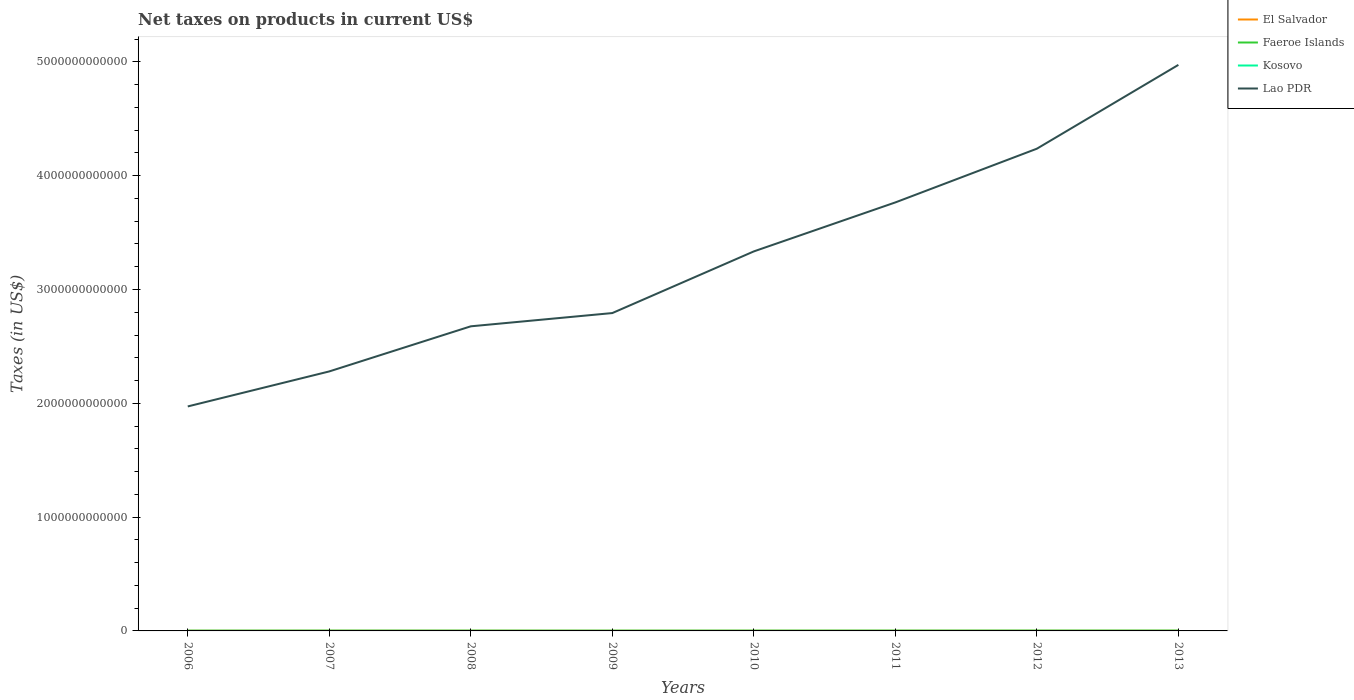How many different coloured lines are there?
Provide a short and direct response. 4. Across all years, what is the maximum net taxes on products in Lao PDR?
Keep it short and to the point. 1.97e+12. In which year was the net taxes on products in Lao PDR maximum?
Provide a succinct answer. 2006. What is the total net taxes on products in Lao PDR in the graph?
Your answer should be very brief. -5.42e+11. What is the difference between the highest and the second highest net taxes on products in Faeroe Islands?
Keep it short and to the point. 2.97e+08. Is the net taxes on products in El Salvador strictly greater than the net taxes on products in Kosovo over the years?
Your response must be concise. No. What is the difference between two consecutive major ticks on the Y-axis?
Your answer should be compact. 1.00e+12. Does the graph contain grids?
Your answer should be very brief. No. Where does the legend appear in the graph?
Provide a short and direct response. Top right. How are the legend labels stacked?
Your response must be concise. Vertical. What is the title of the graph?
Provide a short and direct response. Net taxes on products in current US$. Does "Belize" appear as one of the legend labels in the graph?
Ensure brevity in your answer.  No. What is the label or title of the Y-axis?
Your response must be concise. Taxes (in US$). What is the Taxes (in US$) of El Salvador in 2006?
Your response must be concise. 1.50e+09. What is the Taxes (in US$) in Faeroe Islands in 2006?
Provide a short and direct response. 1.68e+09. What is the Taxes (in US$) of Kosovo in 2006?
Ensure brevity in your answer.  5.34e+08. What is the Taxes (in US$) in Lao PDR in 2006?
Ensure brevity in your answer.  1.97e+12. What is the Taxes (in US$) in El Salvador in 2007?
Keep it short and to the point. 1.69e+09. What is the Taxes (in US$) in Faeroe Islands in 2007?
Your response must be concise. 1.88e+09. What is the Taxes (in US$) in Kosovo in 2007?
Your answer should be compact. 5.87e+08. What is the Taxes (in US$) in Lao PDR in 2007?
Provide a short and direct response. 2.28e+12. What is the Taxes (in US$) of El Salvador in 2008?
Keep it short and to the point. 1.77e+09. What is the Taxes (in US$) in Faeroe Islands in 2008?
Give a very brief answer. 1.78e+09. What is the Taxes (in US$) in Kosovo in 2008?
Your answer should be very brief. 5.91e+08. What is the Taxes (in US$) of Lao PDR in 2008?
Your answer should be compact. 2.68e+12. What is the Taxes (in US$) of El Salvador in 2009?
Keep it short and to the point. 1.52e+09. What is the Taxes (in US$) of Faeroe Islands in 2009?
Provide a succinct answer. 1.58e+09. What is the Taxes (in US$) in Kosovo in 2009?
Give a very brief answer. 6.11e+08. What is the Taxes (in US$) of Lao PDR in 2009?
Keep it short and to the point. 2.79e+12. What is the Taxes (in US$) of El Salvador in 2010?
Your answer should be compact. 1.69e+09. What is the Taxes (in US$) in Faeroe Islands in 2010?
Your answer should be compact. 1.67e+09. What is the Taxes (in US$) in Kosovo in 2010?
Your response must be concise. 7.15e+08. What is the Taxes (in US$) of Lao PDR in 2010?
Make the answer very short. 3.33e+12. What is the Taxes (in US$) of El Salvador in 2011?
Ensure brevity in your answer.  1.95e+09. What is the Taxes (in US$) in Faeroe Islands in 2011?
Your answer should be very brief. 1.65e+09. What is the Taxes (in US$) in Kosovo in 2011?
Make the answer very short. 8.70e+08. What is the Taxes (in US$) in Lao PDR in 2011?
Offer a very short reply. 3.76e+12. What is the Taxes (in US$) in El Salvador in 2012?
Offer a very short reply. 2.03e+09. What is the Taxes (in US$) in Faeroe Islands in 2012?
Provide a short and direct response. 1.71e+09. What is the Taxes (in US$) in Kosovo in 2012?
Your response must be concise. 8.92e+08. What is the Taxes (in US$) of Lao PDR in 2012?
Provide a short and direct response. 4.24e+12. What is the Taxes (in US$) in El Salvador in 2013?
Offer a terse response. 2.10e+09. What is the Taxes (in US$) in Faeroe Islands in 2013?
Provide a short and direct response. 1.69e+09. What is the Taxes (in US$) of Kosovo in 2013?
Offer a terse response. 8.91e+08. What is the Taxes (in US$) of Lao PDR in 2013?
Your answer should be very brief. 4.97e+12. Across all years, what is the maximum Taxes (in US$) of El Salvador?
Make the answer very short. 2.10e+09. Across all years, what is the maximum Taxes (in US$) in Faeroe Islands?
Give a very brief answer. 1.88e+09. Across all years, what is the maximum Taxes (in US$) of Kosovo?
Make the answer very short. 8.92e+08. Across all years, what is the maximum Taxes (in US$) in Lao PDR?
Provide a short and direct response. 4.97e+12. Across all years, what is the minimum Taxes (in US$) of El Salvador?
Give a very brief answer. 1.50e+09. Across all years, what is the minimum Taxes (in US$) of Faeroe Islands?
Offer a very short reply. 1.58e+09. Across all years, what is the minimum Taxes (in US$) of Kosovo?
Offer a very short reply. 5.34e+08. Across all years, what is the minimum Taxes (in US$) of Lao PDR?
Provide a succinct answer. 1.97e+12. What is the total Taxes (in US$) of El Salvador in the graph?
Keep it short and to the point. 1.42e+1. What is the total Taxes (in US$) in Faeroe Islands in the graph?
Your answer should be very brief. 1.36e+1. What is the total Taxes (in US$) in Kosovo in the graph?
Offer a terse response. 5.69e+09. What is the total Taxes (in US$) of Lao PDR in the graph?
Provide a succinct answer. 2.60e+13. What is the difference between the Taxes (in US$) in El Salvador in 2006 and that in 2007?
Offer a very short reply. -1.87e+08. What is the difference between the Taxes (in US$) in Faeroe Islands in 2006 and that in 2007?
Keep it short and to the point. -1.99e+08. What is the difference between the Taxes (in US$) of Kosovo in 2006 and that in 2007?
Your answer should be compact. -5.33e+07. What is the difference between the Taxes (in US$) of Lao PDR in 2006 and that in 2007?
Your response must be concise. -3.08e+11. What is the difference between the Taxes (in US$) in El Salvador in 2006 and that in 2008?
Your response must be concise. -2.76e+08. What is the difference between the Taxes (in US$) of Faeroe Islands in 2006 and that in 2008?
Your answer should be very brief. -1.00e+08. What is the difference between the Taxes (in US$) of Kosovo in 2006 and that in 2008?
Your answer should be compact. -5.71e+07. What is the difference between the Taxes (in US$) in Lao PDR in 2006 and that in 2008?
Make the answer very short. -7.04e+11. What is the difference between the Taxes (in US$) of El Salvador in 2006 and that in 2009?
Your answer should be compact. -2.01e+07. What is the difference between the Taxes (in US$) in Faeroe Islands in 2006 and that in 2009?
Offer a very short reply. 9.80e+07. What is the difference between the Taxes (in US$) of Kosovo in 2006 and that in 2009?
Offer a terse response. -7.67e+07. What is the difference between the Taxes (in US$) of Lao PDR in 2006 and that in 2009?
Your response must be concise. -8.20e+11. What is the difference between the Taxes (in US$) of El Salvador in 2006 and that in 2010?
Offer a very short reply. -1.89e+08. What is the difference between the Taxes (in US$) in Faeroe Islands in 2006 and that in 2010?
Make the answer very short. 1.70e+07. What is the difference between the Taxes (in US$) of Kosovo in 2006 and that in 2010?
Make the answer very short. -1.81e+08. What is the difference between the Taxes (in US$) of Lao PDR in 2006 and that in 2010?
Offer a very short reply. -1.36e+12. What is the difference between the Taxes (in US$) of El Salvador in 2006 and that in 2011?
Your answer should be compact. -4.52e+08. What is the difference between the Taxes (in US$) of Faeroe Islands in 2006 and that in 2011?
Make the answer very short. 3.50e+07. What is the difference between the Taxes (in US$) in Kosovo in 2006 and that in 2011?
Make the answer very short. -3.36e+08. What is the difference between the Taxes (in US$) in Lao PDR in 2006 and that in 2011?
Make the answer very short. -1.79e+12. What is the difference between the Taxes (in US$) in El Salvador in 2006 and that in 2012?
Give a very brief answer. -5.32e+08. What is the difference between the Taxes (in US$) of Faeroe Islands in 2006 and that in 2012?
Your answer should be very brief. -2.30e+07. What is the difference between the Taxes (in US$) of Kosovo in 2006 and that in 2012?
Offer a terse response. -3.58e+08. What is the difference between the Taxes (in US$) in Lao PDR in 2006 and that in 2012?
Offer a very short reply. -2.26e+12. What is the difference between the Taxes (in US$) in El Salvador in 2006 and that in 2013?
Your answer should be compact. -5.97e+08. What is the difference between the Taxes (in US$) of Faeroe Islands in 2006 and that in 2013?
Keep it short and to the point. -1.00e+07. What is the difference between the Taxes (in US$) in Kosovo in 2006 and that in 2013?
Provide a succinct answer. -3.57e+08. What is the difference between the Taxes (in US$) of Lao PDR in 2006 and that in 2013?
Offer a terse response. -3.00e+12. What is the difference between the Taxes (in US$) in El Salvador in 2007 and that in 2008?
Keep it short and to the point. -8.86e+07. What is the difference between the Taxes (in US$) in Faeroe Islands in 2007 and that in 2008?
Provide a succinct answer. 9.90e+07. What is the difference between the Taxes (in US$) of Kosovo in 2007 and that in 2008?
Your answer should be very brief. -3.80e+06. What is the difference between the Taxes (in US$) in Lao PDR in 2007 and that in 2008?
Your answer should be compact. -3.96e+11. What is the difference between the Taxes (in US$) in El Salvador in 2007 and that in 2009?
Your answer should be very brief. 1.67e+08. What is the difference between the Taxes (in US$) in Faeroe Islands in 2007 and that in 2009?
Your answer should be compact. 2.97e+08. What is the difference between the Taxes (in US$) of Kosovo in 2007 and that in 2009?
Ensure brevity in your answer.  -2.34e+07. What is the difference between the Taxes (in US$) of Lao PDR in 2007 and that in 2009?
Your answer should be compact. -5.13e+11. What is the difference between the Taxes (in US$) in El Salvador in 2007 and that in 2010?
Give a very brief answer. -1.50e+06. What is the difference between the Taxes (in US$) of Faeroe Islands in 2007 and that in 2010?
Make the answer very short. 2.16e+08. What is the difference between the Taxes (in US$) in Kosovo in 2007 and that in 2010?
Your response must be concise. -1.28e+08. What is the difference between the Taxes (in US$) of Lao PDR in 2007 and that in 2010?
Give a very brief answer. -1.05e+12. What is the difference between the Taxes (in US$) of El Salvador in 2007 and that in 2011?
Your answer should be compact. -2.65e+08. What is the difference between the Taxes (in US$) of Faeroe Islands in 2007 and that in 2011?
Your answer should be very brief. 2.34e+08. What is the difference between the Taxes (in US$) of Kosovo in 2007 and that in 2011?
Provide a short and direct response. -2.82e+08. What is the difference between the Taxes (in US$) in Lao PDR in 2007 and that in 2011?
Provide a succinct answer. -1.48e+12. What is the difference between the Taxes (in US$) in El Salvador in 2007 and that in 2012?
Provide a succinct answer. -3.45e+08. What is the difference between the Taxes (in US$) in Faeroe Islands in 2007 and that in 2012?
Offer a very short reply. 1.76e+08. What is the difference between the Taxes (in US$) in Kosovo in 2007 and that in 2012?
Give a very brief answer. -3.04e+08. What is the difference between the Taxes (in US$) in Lao PDR in 2007 and that in 2012?
Provide a succinct answer. -1.96e+12. What is the difference between the Taxes (in US$) of El Salvador in 2007 and that in 2013?
Provide a succinct answer. -4.10e+08. What is the difference between the Taxes (in US$) in Faeroe Islands in 2007 and that in 2013?
Keep it short and to the point. 1.89e+08. What is the difference between the Taxes (in US$) in Kosovo in 2007 and that in 2013?
Give a very brief answer. -3.04e+08. What is the difference between the Taxes (in US$) in Lao PDR in 2007 and that in 2013?
Ensure brevity in your answer.  -2.69e+12. What is the difference between the Taxes (in US$) of El Salvador in 2008 and that in 2009?
Give a very brief answer. 2.56e+08. What is the difference between the Taxes (in US$) in Faeroe Islands in 2008 and that in 2009?
Provide a short and direct response. 1.98e+08. What is the difference between the Taxes (in US$) of Kosovo in 2008 and that in 2009?
Offer a very short reply. -1.96e+07. What is the difference between the Taxes (in US$) of Lao PDR in 2008 and that in 2009?
Your answer should be compact. -1.16e+11. What is the difference between the Taxes (in US$) in El Salvador in 2008 and that in 2010?
Keep it short and to the point. 8.71e+07. What is the difference between the Taxes (in US$) in Faeroe Islands in 2008 and that in 2010?
Provide a short and direct response. 1.17e+08. What is the difference between the Taxes (in US$) of Kosovo in 2008 and that in 2010?
Provide a short and direct response. -1.24e+08. What is the difference between the Taxes (in US$) in Lao PDR in 2008 and that in 2010?
Keep it short and to the point. -6.58e+11. What is the difference between the Taxes (in US$) in El Salvador in 2008 and that in 2011?
Keep it short and to the point. -1.76e+08. What is the difference between the Taxes (in US$) of Faeroe Islands in 2008 and that in 2011?
Provide a succinct answer. 1.35e+08. What is the difference between the Taxes (in US$) of Kosovo in 2008 and that in 2011?
Offer a very short reply. -2.79e+08. What is the difference between the Taxes (in US$) of Lao PDR in 2008 and that in 2011?
Offer a very short reply. -1.09e+12. What is the difference between the Taxes (in US$) of El Salvador in 2008 and that in 2012?
Ensure brevity in your answer.  -2.56e+08. What is the difference between the Taxes (in US$) of Faeroe Islands in 2008 and that in 2012?
Your answer should be compact. 7.70e+07. What is the difference between the Taxes (in US$) in Kosovo in 2008 and that in 2012?
Your answer should be compact. -3.01e+08. What is the difference between the Taxes (in US$) in Lao PDR in 2008 and that in 2012?
Your answer should be compact. -1.56e+12. What is the difference between the Taxes (in US$) in El Salvador in 2008 and that in 2013?
Give a very brief answer. -3.22e+08. What is the difference between the Taxes (in US$) in Faeroe Islands in 2008 and that in 2013?
Your response must be concise. 9.00e+07. What is the difference between the Taxes (in US$) in Kosovo in 2008 and that in 2013?
Provide a succinct answer. -3.00e+08. What is the difference between the Taxes (in US$) of Lao PDR in 2008 and that in 2013?
Your answer should be compact. -2.30e+12. What is the difference between the Taxes (in US$) in El Salvador in 2009 and that in 2010?
Your answer should be very brief. -1.68e+08. What is the difference between the Taxes (in US$) of Faeroe Islands in 2009 and that in 2010?
Offer a terse response. -8.10e+07. What is the difference between the Taxes (in US$) in Kosovo in 2009 and that in 2010?
Give a very brief answer. -1.04e+08. What is the difference between the Taxes (in US$) in Lao PDR in 2009 and that in 2010?
Provide a succinct answer. -5.42e+11. What is the difference between the Taxes (in US$) in El Salvador in 2009 and that in 2011?
Offer a terse response. -4.32e+08. What is the difference between the Taxes (in US$) of Faeroe Islands in 2009 and that in 2011?
Keep it short and to the point. -6.30e+07. What is the difference between the Taxes (in US$) in Kosovo in 2009 and that in 2011?
Make the answer very short. -2.59e+08. What is the difference between the Taxes (in US$) in Lao PDR in 2009 and that in 2011?
Your answer should be very brief. -9.72e+11. What is the difference between the Taxes (in US$) in El Salvador in 2009 and that in 2012?
Your answer should be very brief. -5.12e+08. What is the difference between the Taxes (in US$) in Faeroe Islands in 2009 and that in 2012?
Your answer should be compact. -1.21e+08. What is the difference between the Taxes (in US$) of Kosovo in 2009 and that in 2012?
Provide a succinct answer. -2.81e+08. What is the difference between the Taxes (in US$) of Lao PDR in 2009 and that in 2012?
Your answer should be compact. -1.44e+12. What is the difference between the Taxes (in US$) of El Salvador in 2009 and that in 2013?
Provide a short and direct response. -5.77e+08. What is the difference between the Taxes (in US$) of Faeroe Islands in 2009 and that in 2013?
Keep it short and to the point. -1.08e+08. What is the difference between the Taxes (in US$) in Kosovo in 2009 and that in 2013?
Offer a terse response. -2.80e+08. What is the difference between the Taxes (in US$) of Lao PDR in 2009 and that in 2013?
Offer a terse response. -2.18e+12. What is the difference between the Taxes (in US$) in El Salvador in 2010 and that in 2011?
Give a very brief answer. -2.64e+08. What is the difference between the Taxes (in US$) of Faeroe Islands in 2010 and that in 2011?
Your answer should be compact. 1.80e+07. What is the difference between the Taxes (in US$) of Kosovo in 2010 and that in 2011?
Ensure brevity in your answer.  -1.55e+08. What is the difference between the Taxes (in US$) of Lao PDR in 2010 and that in 2011?
Your answer should be compact. -4.30e+11. What is the difference between the Taxes (in US$) in El Salvador in 2010 and that in 2012?
Give a very brief answer. -3.44e+08. What is the difference between the Taxes (in US$) of Faeroe Islands in 2010 and that in 2012?
Your answer should be compact. -4.00e+07. What is the difference between the Taxes (in US$) of Kosovo in 2010 and that in 2012?
Your answer should be compact. -1.77e+08. What is the difference between the Taxes (in US$) of Lao PDR in 2010 and that in 2012?
Offer a very short reply. -9.02e+11. What is the difference between the Taxes (in US$) of El Salvador in 2010 and that in 2013?
Make the answer very short. -4.09e+08. What is the difference between the Taxes (in US$) in Faeroe Islands in 2010 and that in 2013?
Your response must be concise. -2.70e+07. What is the difference between the Taxes (in US$) in Kosovo in 2010 and that in 2013?
Make the answer very short. -1.76e+08. What is the difference between the Taxes (in US$) in Lao PDR in 2010 and that in 2013?
Provide a short and direct response. -1.64e+12. What is the difference between the Taxes (in US$) of El Salvador in 2011 and that in 2012?
Ensure brevity in your answer.  -8.00e+07. What is the difference between the Taxes (in US$) of Faeroe Islands in 2011 and that in 2012?
Your response must be concise. -5.80e+07. What is the difference between the Taxes (in US$) in Kosovo in 2011 and that in 2012?
Offer a very short reply. -2.21e+07. What is the difference between the Taxes (in US$) of Lao PDR in 2011 and that in 2012?
Give a very brief answer. -4.72e+11. What is the difference between the Taxes (in US$) in El Salvador in 2011 and that in 2013?
Provide a succinct answer. -1.45e+08. What is the difference between the Taxes (in US$) of Faeroe Islands in 2011 and that in 2013?
Your answer should be compact. -4.50e+07. What is the difference between the Taxes (in US$) in Kosovo in 2011 and that in 2013?
Your response must be concise. -2.14e+07. What is the difference between the Taxes (in US$) of Lao PDR in 2011 and that in 2013?
Your response must be concise. -1.21e+12. What is the difference between the Taxes (in US$) in El Salvador in 2012 and that in 2013?
Make the answer very short. -6.53e+07. What is the difference between the Taxes (in US$) of Faeroe Islands in 2012 and that in 2013?
Ensure brevity in your answer.  1.30e+07. What is the difference between the Taxes (in US$) of Lao PDR in 2012 and that in 2013?
Give a very brief answer. -7.37e+11. What is the difference between the Taxes (in US$) of El Salvador in 2006 and the Taxes (in US$) of Faeroe Islands in 2007?
Keep it short and to the point. -3.83e+08. What is the difference between the Taxes (in US$) in El Salvador in 2006 and the Taxes (in US$) in Kosovo in 2007?
Give a very brief answer. 9.11e+08. What is the difference between the Taxes (in US$) in El Salvador in 2006 and the Taxes (in US$) in Lao PDR in 2007?
Give a very brief answer. -2.28e+12. What is the difference between the Taxes (in US$) of Faeroe Islands in 2006 and the Taxes (in US$) of Kosovo in 2007?
Offer a very short reply. 1.10e+09. What is the difference between the Taxes (in US$) in Faeroe Islands in 2006 and the Taxes (in US$) in Lao PDR in 2007?
Your response must be concise. -2.28e+12. What is the difference between the Taxes (in US$) in Kosovo in 2006 and the Taxes (in US$) in Lao PDR in 2007?
Provide a short and direct response. -2.28e+12. What is the difference between the Taxes (in US$) of El Salvador in 2006 and the Taxes (in US$) of Faeroe Islands in 2008?
Your response must be concise. -2.84e+08. What is the difference between the Taxes (in US$) in El Salvador in 2006 and the Taxes (in US$) in Kosovo in 2008?
Give a very brief answer. 9.08e+08. What is the difference between the Taxes (in US$) of El Salvador in 2006 and the Taxes (in US$) of Lao PDR in 2008?
Offer a terse response. -2.67e+12. What is the difference between the Taxes (in US$) in Faeroe Islands in 2006 and the Taxes (in US$) in Kosovo in 2008?
Offer a terse response. 1.09e+09. What is the difference between the Taxes (in US$) in Faeroe Islands in 2006 and the Taxes (in US$) in Lao PDR in 2008?
Keep it short and to the point. -2.67e+12. What is the difference between the Taxes (in US$) in Kosovo in 2006 and the Taxes (in US$) in Lao PDR in 2008?
Make the answer very short. -2.68e+12. What is the difference between the Taxes (in US$) of El Salvador in 2006 and the Taxes (in US$) of Faeroe Islands in 2009?
Keep it short and to the point. -8.64e+07. What is the difference between the Taxes (in US$) in El Salvador in 2006 and the Taxes (in US$) in Kosovo in 2009?
Your response must be concise. 8.88e+08. What is the difference between the Taxes (in US$) in El Salvador in 2006 and the Taxes (in US$) in Lao PDR in 2009?
Your answer should be compact. -2.79e+12. What is the difference between the Taxes (in US$) in Faeroe Islands in 2006 and the Taxes (in US$) in Kosovo in 2009?
Ensure brevity in your answer.  1.07e+09. What is the difference between the Taxes (in US$) of Faeroe Islands in 2006 and the Taxes (in US$) of Lao PDR in 2009?
Offer a terse response. -2.79e+12. What is the difference between the Taxes (in US$) in Kosovo in 2006 and the Taxes (in US$) in Lao PDR in 2009?
Provide a short and direct response. -2.79e+12. What is the difference between the Taxes (in US$) of El Salvador in 2006 and the Taxes (in US$) of Faeroe Islands in 2010?
Give a very brief answer. -1.67e+08. What is the difference between the Taxes (in US$) of El Salvador in 2006 and the Taxes (in US$) of Kosovo in 2010?
Ensure brevity in your answer.  7.84e+08. What is the difference between the Taxes (in US$) in El Salvador in 2006 and the Taxes (in US$) in Lao PDR in 2010?
Your answer should be very brief. -3.33e+12. What is the difference between the Taxes (in US$) in Faeroe Islands in 2006 and the Taxes (in US$) in Kosovo in 2010?
Provide a succinct answer. 9.68e+08. What is the difference between the Taxes (in US$) of Faeroe Islands in 2006 and the Taxes (in US$) of Lao PDR in 2010?
Offer a very short reply. -3.33e+12. What is the difference between the Taxes (in US$) in Kosovo in 2006 and the Taxes (in US$) in Lao PDR in 2010?
Offer a terse response. -3.33e+12. What is the difference between the Taxes (in US$) of El Salvador in 2006 and the Taxes (in US$) of Faeroe Islands in 2011?
Keep it short and to the point. -1.49e+08. What is the difference between the Taxes (in US$) of El Salvador in 2006 and the Taxes (in US$) of Kosovo in 2011?
Your answer should be very brief. 6.29e+08. What is the difference between the Taxes (in US$) of El Salvador in 2006 and the Taxes (in US$) of Lao PDR in 2011?
Offer a very short reply. -3.76e+12. What is the difference between the Taxes (in US$) in Faeroe Islands in 2006 and the Taxes (in US$) in Kosovo in 2011?
Make the answer very short. 8.13e+08. What is the difference between the Taxes (in US$) in Faeroe Islands in 2006 and the Taxes (in US$) in Lao PDR in 2011?
Make the answer very short. -3.76e+12. What is the difference between the Taxes (in US$) in Kosovo in 2006 and the Taxes (in US$) in Lao PDR in 2011?
Your response must be concise. -3.76e+12. What is the difference between the Taxes (in US$) in El Salvador in 2006 and the Taxes (in US$) in Faeroe Islands in 2012?
Ensure brevity in your answer.  -2.07e+08. What is the difference between the Taxes (in US$) in El Salvador in 2006 and the Taxes (in US$) in Kosovo in 2012?
Provide a short and direct response. 6.07e+08. What is the difference between the Taxes (in US$) of El Salvador in 2006 and the Taxes (in US$) of Lao PDR in 2012?
Your answer should be compact. -4.24e+12. What is the difference between the Taxes (in US$) in Faeroe Islands in 2006 and the Taxes (in US$) in Kosovo in 2012?
Keep it short and to the point. 7.91e+08. What is the difference between the Taxes (in US$) of Faeroe Islands in 2006 and the Taxes (in US$) of Lao PDR in 2012?
Make the answer very short. -4.24e+12. What is the difference between the Taxes (in US$) of Kosovo in 2006 and the Taxes (in US$) of Lao PDR in 2012?
Keep it short and to the point. -4.24e+12. What is the difference between the Taxes (in US$) in El Salvador in 2006 and the Taxes (in US$) in Faeroe Islands in 2013?
Keep it short and to the point. -1.94e+08. What is the difference between the Taxes (in US$) in El Salvador in 2006 and the Taxes (in US$) in Kosovo in 2013?
Offer a terse response. 6.08e+08. What is the difference between the Taxes (in US$) in El Salvador in 2006 and the Taxes (in US$) in Lao PDR in 2013?
Your answer should be very brief. -4.97e+12. What is the difference between the Taxes (in US$) in Faeroe Islands in 2006 and the Taxes (in US$) in Kosovo in 2013?
Make the answer very short. 7.92e+08. What is the difference between the Taxes (in US$) of Faeroe Islands in 2006 and the Taxes (in US$) of Lao PDR in 2013?
Provide a succinct answer. -4.97e+12. What is the difference between the Taxes (in US$) in Kosovo in 2006 and the Taxes (in US$) in Lao PDR in 2013?
Provide a short and direct response. -4.97e+12. What is the difference between the Taxes (in US$) of El Salvador in 2007 and the Taxes (in US$) of Faeroe Islands in 2008?
Give a very brief answer. -9.73e+07. What is the difference between the Taxes (in US$) in El Salvador in 2007 and the Taxes (in US$) in Kosovo in 2008?
Your answer should be very brief. 1.09e+09. What is the difference between the Taxes (in US$) of El Salvador in 2007 and the Taxes (in US$) of Lao PDR in 2008?
Your response must be concise. -2.67e+12. What is the difference between the Taxes (in US$) of Faeroe Islands in 2007 and the Taxes (in US$) of Kosovo in 2008?
Provide a short and direct response. 1.29e+09. What is the difference between the Taxes (in US$) in Faeroe Islands in 2007 and the Taxes (in US$) in Lao PDR in 2008?
Give a very brief answer. -2.67e+12. What is the difference between the Taxes (in US$) in Kosovo in 2007 and the Taxes (in US$) in Lao PDR in 2008?
Your response must be concise. -2.68e+12. What is the difference between the Taxes (in US$) of El Salvador in 2007 and the Taxes (in US$) of Faeroe Islands in 2009?
Your answer should be compact. 1.01e+08. What is the difference between the Taxes (in US$) of El Salvador in 2007 and the Taxes (in US$) of Kosovo in 2009?
Ensure brevity in your answer.  1.08e+09. What is the difference between the Taxes (in US$) in El Salvador in 2007 and the Taxes (in US$) in Lao PDR in 2009?
Give a very brief answer. -2.79e+12. What is the difference between the Taxes (in US$) in Faeroe Islands in 2007 and the Taxes (in US$) in Kosovo in 2009?
Keep it short and to the point. 1.27e+09. What is the difference between the Taxes (in US$) of Faeroe Islands in 2007 and the Taxes (in US$) of Lao PDR in 2009?
Provide a short and direct response. -2.79e+12. What is the difference between the Taxes (in US$) of Kosovo in 2007 and the Taxes (in US$) of Lao PDR in 2009?
Provide a short and direct response. -2.79e+12. What is the difference between the Taxes (in US$) of El Salvador in 2007 and the Taxes (in US$) of Faeroe Islands in 2010?
Your answer should be compact. 1.97e+07. What is the difference between the Taxes (in US$) in El Salvador in 2007 and the Taxes (in US$) in Kosovo in 2010?
Provide a short and direct response. 9.71e+08. What is the difference between the Taxes (in US$) of El Salvador in 2007 and the Taxes (in US$) of Lao PDR in 2010?
Your response must be concise. -3.33e+12. What is the difference between the Taxes (in US$) in Faeroe Islands in 2007 and the Taxes (in US$) in Kosovo in 2010?
Make the answer very short. 1.17e+09. What is the difference between the Taxes (in US$) in Faeroe Islands in 2007 and the Taxes (in US$) in Lao PDR in 2010?
Give a very brief answer. -3.33e+12. What is the difference between the Taxes (in US$) of Kosovo in 2007 and the Taxes (in US$) of Lao PDR in 2010?
Make the answer very short. -3.33e+12. What is the difference between the Taxes (in US$) of El Salvador in 2007 and the Taxes (in US$) of Faeroe Islands in 2011?
Your response must be concise. 3.77e+07. What is the difference between the Taxes (in US$) in El Salvador in 2007 and the Taxes (in US$) in Kosovo in 2011?
Offer a very short reply. 8.16e+08. What is the difference between the Taxes (in US$) in El Salvador in 2007 and the Taxes (in US$) in Lao PDR in 2011?
Make the answer very short. -3.76e+12. What is the difference between the Taxes (in US$) of Faeroe Islands in 2007 and the Taxes (in US$) of Kosovo in 2011?
Provide a succinct answer. 1.01e+09. What is the difference between the Taxes (in US$) in Faeroe Islands in 2007 and the Taxes (in US$) in Lao PDR in 2011?
Your answer should be compact. -3.76e+12. What is the difference between the Taxes (in US$) in Kosovo in 2007 and the Taxes (in US$) in Lao PDR in 2011?
Your answer should be compact. -3.76e+12. What is the difference between the Taxes (in US$) in El Salvador in 2007 and the Taxes (in US$) in Faeroe Islands in 2012?
Provide a short and direct response. -2.03e+07. What is the difference between the Taxes (in US$) in El Salvador in 2007 and the Taxes (in US$) in Kosovo in 2012?
Your answer should be compact. 7.94e+08. What is the difference between the Taxes (in US$) of El Salvador in 2007 and the Taxes (in US$) of Lao PDR in 2012?
Keep it short and to the point. -4.24e+12. What is the difference between the Taxes (in US$) of Faeroe Islands in 2007 and the Taxes (in US$) of Kosovo in 2012?
Provide a short and direct response. 9.90e+08. What is the difference between the Taxes (in US$) in Faeroe Islands in 2007 and the Taxes (in US$) in Lao PDR in 2012?
Make the answer very short. -4.24e+12. What is the difference between the Taxes (in US$) of Kosovo in 2007 and the Taxes (in US$) of Lao PDR in 2012?
Ensure brevity in your answer.  -4.24e+12. What is the difference between the Taxes (in US$) of El Salvador in 2007 and the Taxes (in US$) of Faeroe Islands in 2013?
Provide a succinct answer. -7.30e+06. What is the difference between the Taxes (in US$) in El Salvador in 2007 and the Taxes (in US$) in Kosovo in 2013?
Offer a terse response. 7.95e+08. What is the difference between the Taxes (in US$) in El Salvador in 2007 and the Taxes (in US$) in Lao PDR in 2013?
Provide a succinct answer. -4.97e+12. What is the difference between the Taxes (in US$) in Faeroe Islands in 2007 and the Taxes (in US$) in Kosovo in 2013?
Your answer should be very brief. 9.91e+08. What is the difference between the Taxes (in US$) of Faeroe Islands in 2007 and the Taxes (in US$) of Lao PDR in 2013?
Provide a succinct answer. -4.97e+12. What is the difference between the Taxes (in US$) in Kosovo in 2007 and the Taxes (in US$) in Lao PDR in 2013?
Give a very brief answer. -4.97e+12. What is the difference between the Taxes (in US$) in El Salvador in 2008 and the Taxes (in US$) in Faeroe Islands in 2009?
Make the answer very short. 1.89e+08. What is the difference between the Taxes (in US$) in El Salvador in 2008 and the Taxes (in US$) in Kosovo in 2009?
Your response must be concise. 1.16e+09. What is the difference between the Taxes (in US$) of El Salvador in 2008 and the Taxes (in US$) of Lao PDR in 2009?
Offer a very short reply. -2.79e+12. What is the difference between the Taxes (in US$) of Faeroe Islands in 2008 and the Taxes (in US$) of Kosovo in 2009?
Make the answer very short. 1.17e+09. What is the difference between the Taxes (in US$) of Faeroe Islands in 2008 and the Taxes (in US$) of Lao PDR in 2009?
Offer a terse response. -2.79e+12. What is the difference between the Taxes (in US$) in Kosovo in 2008 and the Taxes (in US$) in Lao PDR in 2009?
Provide a succinct answer. -2.79e+12. What is the difference between the Taxes (in US$) of El Salvador in 2008 and the Taxes (in US$) of Faeroe Islands in 2010?
Your answer should be very brief. 1.08e+08. What is the difference between the Taxes (in US$) in El Salvador in 2008 and the Taxes (in US$) in Kosovo in 2010?
Offer a terse response. 1.06e+09. What is the difference between the Taxes (in US$) in El Salvador in 2008 and the Taxes (in US$) in Lao PDR in 2010?
Your answer should be compact. -3.33e+12. What is the difference between the Taxes (in US$) in Faeroe Islands in 2008 and the Taxes (in US$) in Kosovo in 2010?
Offer a terse response. 1.07e+09. What is the difference between the Taxes (in US$) in Faeroe Islands in 2008 and the Taxes (in US$) in Lao PDR in 2010?
Your answer should be compact. -3.33e+12. What is the difference between the Taxes (in US$) of Kosovo in 2008 and the Taxes (in US$) of Lao PDR in 2010?
Provide a succinct answer. -3.33e+12. What is the difference between the Taxes (in US$) of El Salvador in 2008 and the Taxes (in US$) of Faeroe Islands in 2011?
Your response must be concise. 1.26e+08. What is the difference between the Taxes (in US$) of El Salvador in 2008 and the Taxes (in US$) of Kosovo in 2011?
Your answer should be compact. 9.05e+08. What is the difference between the Taxes (in US$) in El Salvador in 2008 and the Taxes (in US$) in Lao PDR in 2011?
Give a very brief answer. -3.76e+12. What is the difference between the Taxes (in US$) in Faeroe Islands in 2008 and the Taxes (in US$) in Kosovo in 2011?
Offer a very short reply. 9.13e+08. What is the difference between the Taxes (in US$) in Faeroe Islands in 2008 and the Taxes (in US$) in Lao PDR in 2011?
Make the answer very short. -3.76e+12. What is the difference between the Taxes (in US$) in Kosovo in 2008 and the Taxes (in US$) in Lao PDR in 2011?
Provide a short and direct response. -3.76e+12. What is the difference between the Taxes (in US$) of El Salvador in 2008 and the Taxes (in US$) of Faeroe Islands in 2012?
Provide a succinct answer. 6.83e+07. What is the difference between the Taxes (in US$) in El Salvador in 2008 and the Taxes (in US$) in Kosovo in 2012?
Offer a very short reply. 8.82e+08. What is the difference between the Taxes (in US$) of El Salvador in 2008 and the Taxes (in US$) of Lao PDR in 2012?
Your answer should be compact. -4.24e+12. What is the difference between the Taxes (in US$) of Faeroe Islands in 2008 and the Taxes (in US$) of Kosovo in 2012?
Ensure brevity in your answer.  8.91e+08. What is the difference between the Taxes (in US$) in Faeroe Islands in 2008 and the Taxes (in US$) in Lao PDR in 2012?
Your answer should be compact. -4.24e+12. What is the difference between the Taxes (in US$) in Kosovo in 2008 and the Taxes (in US$) in Lao PDR in 2012?
Ensure brevity in your answer.  -4.24e+12. What is the difference between the Taxes (in US$) in El Salvador in 2008 and the Taxes (in US$) in Faeroe Islands in 2013?
Give a very brief answer. 8.13e+07. What is the difference between the Taxes (in US$) of El Salvador in 2008 and the Taxes (in US$) of Kosovo in 2013?
Your answer should be very brief. 8.83e+08. What is the difference between the Taxes (in US$) of El Salvador in 2008 and the Taxes (in US$) of Lao PDR in 2013?
Your response must be concise. -4.97e+12. What is the difference between the Taxes (in US$) in Faeroe Islands in 2008 and the Taxes (in US$) in Kosovo in 2013?
Your response must be concise. 8.92e+08. What is the difference between the Taxes (in US$) of Faeroe Islands in 2008 and the Taxes (in US$) of Lao PDR in 2013?
Your answer should be compact. -4.97e+12. What is the difference between the Taxes (in US$) of Kosovo in 2008 and the Taxes (in US$) of Lao PDR in 2013?
Offer a terse response. -4.97e+12. What is the difference between the Taxes (in US$) in El Salvador in 2009 and the Taxes (in US$) in Faeroe Islands in 2010?
Keep it short and to the point. -1.47e+08. What is the difference between the Taxes (in US$) of El Salvador in 2009 and the Taxes (in US$) of Kosovo in 2010?
Your answer should be compact. 8.04e+08. What is the difference between the Taxes (in US$) of El Salvador in 2009 and the Taxes (in US$) of Lao PDR in 2010?
Ensure brevity in your answer.  -3.33e+12. What is the difference between the Taxes (in US$) in Faeroe Islands in 2009 and the Taxes (in US$) in Kosovo in 2010?
Provide a short and direct response. 8.70e+08. What is the difference between the Taxes (in US$) in Faeroe Islands in 2009 and the Taxes (in US$) in Lao PDR in 2010?
Provide a short and direct response. -3.33e+12. What is the difference between the Taxes (in US$) in Kosovo in 2009 and the Taxes (in US$) in Lao PDR in 2010?
Your response must be concise. -3.33e+12. What is the difference between the Taxes (in US$) of El Salvador in 2009 and the Taxes (in US$) of Faeroe Islands in 2011?
Your response must be concise. -1.29e+08. What is the difference between the Taxes (in US$) of El Salvador in 2009 and the Taxes (in US$) of Kosovo in 2011?
Offer a very short reply. 6.49e+08. What is the difference between the Taxes (in US$) in El Salvador in 2009 and the Taxes (in US$) in Lao PDR in 2011?
Make the answer very short. -3.76e+12. What is the difference between the Taxes (in US$) of Faeroe Islands in 2009 and the Taxes (in US$) of Kosovo in 2011?
Your response must be concise. 7.15e+08. What is the difference between the Taxes (in US$) in Faeroe Islands in 2009 and the Taxes (in US$) in Lao PDR in 2011?
Offer a terse response. -3.76e+12. What is the difference between the Taxes (in US$) of Kosovo in 2009 and the Taxes (in US$) of Lao PDR in 2011?
Your response must be concise. -3.76e+12. What is the difference between the Taxes (in US$) of El Salvador in 2009 and the Taxes (in US$) of Faeroe Islands in 2012?
Provide a short and direct response. -1.87e+08. What is the difference between the Taxes (in US$) in El Salvador in 2009 and the Taxes (in US$) in Kosovo in 2012?
Give a very brief answer. 6.27e+08. What is the difference between the Taxes (in US$) in El Salvador in 2009 and the Taxes (in US$) in Lao PDR in 2012?
Provide a short and direct response. -4.24e+12. What is the difference between the Taxes (in US$) in Faeroe Islands in 2009 and the Taxes (in US$) in Kosovo in 2012?
Offer a terse response. 6.93e+08. What is the difference between the Taxes (in US$) of Faeroe Islands in 2009 and the Taxes (in US$) of Lao PDR in 2012?
Give a very brief answer. -4.24e+12. What is the difference between the Taxes (in US$) of Kosovo in 2009 and the Taxes (in US$) of Lao PDR in 2012?
Provide a short and direct response. -4.24e+12. What is the difference between the Taxes (in US$) in El Salvador in 2009 and the Taxes (in US$) in Faeroe Islands in 2013?
Offer a very short reply. -1.74e+08. What is the difference between the Taxes (in US$) in El Salvador in 2009 and the Taxes (in US$) in Kosovo in 2013?
Keep it short and to the point. 6.28e+08. What is the difference between the Taxes (in US$) in El Salvador in 2009 and the Taxes (in US$) in Lao PDR in 2013?
Provide a short and direct response. -4.97e+12. What is the difference between the Taxes (in US$) of Faeroe Islands in 2009 and the Taxes (in US$) of Kosovo in 2013?
Your response must be concise. 6.94e+08. What is the difference between the Taxes (in US$) in Faeroe Islands in 2009 and the Taxes (in US$) in Lao PDR in 2013?
Offer a terse response. -4.97e+12. What is the difference between the Taxes (in US$) in Kosovo in 2009 and the Taxes (in US$) in Lao PDR in 2013?
Keep it short and to the point. -4.97e+12. What is the difference between the Taxes (in US$) of El Salvador in 2010 and the Taxes (in US$) of Faeroe Islands in 2011?
Ensure brevity in your answer.  3.92e+07. What is the difference between the Taxes (in US$) in El Salvador in 2010 and the Taxes (in US$) in Kosovo in 2011?
Offer a terse response. 8.18e+08. What is the difference between the Taxes (in US$) in El Salvador in 2010 and the Taxes (in US$) in Lao PDR in 2011?
Make the answer very short. -3.76e+12. What is the difference between the Taxes (in US$) of Faeroe Islands in 2010 and the Taxes (in US$) of Kosovo in 2011?
Ensure brevity in your answer.  7.96e+08. What is the difference between the Taxes (in US$) in Faeroe Islands in 2010 and the Taxes (in US$) in Lao PDR in 2011?
Provide a short and direct response. -3.76e+12. What is the difference between the Taxes (in US$) in Kosovo in 2010 and the Taxes (in US$) in Lao PDR in 2011?
Keep it short and to the point. -3.76e+12. What is the difference between the Taxes (in US$) of El Salvador in 2010 and the Taxes (in US$) of Faeroe Islands in 2012?
Provide a succinct answer. -1.88e+07. What is the difference between the Taxes (in US$) of El Salvador in 2010 and the Taxes (in US$) of Kosovo in 2012?
Make the answer very short. 7.95e+08. What is the difference between the Taxes (in US$) of El Salvador in 2010 and the Taxes (in US$) of Lao PDR in 2012?
Keep it short and to the point. -4.24e+12. What is the difference between the Taxes (in US$) of Faeroe Islands in 2010 and the Taxes (in US$) of Kosovo in 2012?
Your answer should be compact. 7.74e+08. What is the difference between the Taxes (in US$) in Faeroe Islands in 2010 and the Taxes (in US$) in Lao PDR in 2012?
Ensure brevity in your answer.  -4.24e+12. What is the difference between the Taxes (in US$) in Kosovo in 2010 and the Taxes (in US$) in Lao PDR in 2012?
Provide a short and direct response. -4.24e+12. What is the difference between the Taxes (in US$) in El Salvador in 2010 and the Taxes (in US$) in Faeroe Islands in 2013?
Give a very brief answer. -5.80e+06. What is the difference between the Taxes (in US$) of El Salvador in 2010 and the Taxes (in US$) of Kosovo in 2013?
Your answer should be compact. 7.96e+08. What is the difference between the Taxes (in US$) in El Salvador in 2010 and the Taxes (in US$) in Lao PDR in 2013?
Give a very brief answer. -4.97e+12. What is the difference between the Taxes (in US$) in Faeroe Islands in 2010 and the Taxes (in US$) in Kosovo in 2013?
Provide a succinct answer. 7.75e+08. What is the difference between the Taxes (in US$) in Faeroe Islands in 2010 and the Taxes (in US$) in Lao PDR in 2013?
Your answer should be very brief. -4.97e+12. What is the difference between the Taxes (in US$) in Kosovo in 2010 and the Taxes (in US$) in Lao PDR in 2013?
Ensure brevity in your answer.  -4.97e+12. What is the difference between the Taxes (in US$) of El Salvador in 2011 and the Taxes (in US$) of Faeroe Islands in 2012?
Offer a terse response. 2.45e+08. What is the difference between the Taxes (in US$) of El Salvador in 2011 and the Taxes (in US$) of Kosovo in 2012?
Make the answer very short. 1.06e+09. What is the difference between the Taxes (in US$) of El Salvador in 2011 and the Taxes (in US$) of Lao PDR in 2012?
Your answer should be compact. -4.24e+12. What is the difference between the Taxes (in US$) of Faeroe Islands in 2011 and the Taxes (in US$) of Kosovo in 2012?
Provide a short and direct response. 7.56e+08. What is the difference between the Taxes (in US$) in Faeroe Islands in 2011 and the Taxes (in US$) in Lao PDR in 2012?
Your response must be concise. -4.24e+12. What is the difference between the Taxes (in US$) of Kosovo in 2011 and the Taxes (in US$) of Lao PDR in 2012?
Your answer should be compact. -4.24e+12. What is the difference between the Taxes (in US$) of El Salvador in 2011 and the Taxes (in US$) of Faeroe Islands in 2013?
Your response must be concise. 2.58e+08. What is the difference between the Taxes (in US$) of El Salvador in 2011 and the Taxes (in US$) of Kosovo in 2013?
Your answer should be very brief. 1.06e+09. What is the difference between the Taxes (in US$) in El Salvador in 2011 and the Taxes (in US$) in Lao PDR in 2013?
Give a very brief answer. -4.97e+12. What is the difference between the Taxes (in US$) in Faeroe Islands in 2011 and the Taxes (in US$) in Kosovo in 2013?
Provide a succinct answer. 7.57e+08. What is the difference between the Taxes (in US$) in Faeroe Islands in 2011 and the Taxes (in US$) in Lao PDR in 2013?
Give a very brief answer. -4.97e+12. What is the difference between the Taxes (in US$) of Kosovo in 2011 and the Taxes (in US$) of Lao PDR in 2013?
Ensure brevity in your answer.  -4.97e+12. What is the difference between the Taxes (in US$) of El Salvador in 2012 and the Taxes (in US$) of Faeroe Islands in 2013?
Give a very brief answer. 3.38e+08. What is the difference between the Taxes (in US$) in El Salvador in 2012 and the Taxes (in US$) in Kosovo in 2013?
Provide a short and direct response. 1.14e+09. What is the difference between the Taxes (in US$) in El Salvador in 2012 and the Taxes (in US$) in Lao PDR in 2013?
Offer a very short reply. -4.97e+12. What is the difference between the Taxes (in US$) in Faeroe Islands in 2012 and the Taxes (in US$) in Kosovo in 2013?
Provide a short and direct response. 8.15e+08. What is the difference between the Taxes (in US$) of Faeroe Islands in 2012 and the Taxes (in US$) of Lao PDR in 2013?
Ensure brevity in your answer.  -4.97e+12. What is the difference between the Taxes (in US$) of Kosovo in 2012 and the Taxes (in US$) of Lao PDR in 2013?
Offer a terse response. -4.97e+12. What is the average Taxes (in US$) in El Salvador per year?
Offer a very short reply. 1.78e+09. What is the average Taxes (in US$) of Faeroe Islands per year?
Provide a short and direct response. 1.71e+09. What is the average Taxes (in US$) in Kosovo per year?
Your response must be concise. 7.11e+08. What is the average Taxes (in US$) in Lao PDR per year?
Your response must be concise. 3.25e+12. In the year 2006, what is the difference between the Taxes (in US$) of El Salvador and Taxes (in US$) of Faeroe Islands?
Ensure brevity in your answer.  -1.84e+08. In the year 2006, what is the difference between the Taxes (in US$) of El Salvador and Taxes (in US$) of Kosovo?
Give a very brief answer. 9.65e+08. In the year 2006, what is the difference between the Taxes (in US$) in El Salvador and Taxes (in US$) in Lao PDR?
Keep it short and to the point. -1.97e+12. In the year 2006, what is the difference between the Taxes (in US$) of Faeroe Islands and Taxes (in US$) of Kosovo?
Your answer should be very brief. 1.15e+09. In the year 2006, what is the difference between the Taxes (in US$) in Faeroe Islands and Taxes (in US$) in Lao PDR?
Your answer should be compact. -1.97e+12. In the year 2006, what is the difference between the Taxes (in US$) of Kosovo and Taxes (in US$) of Lao PDR?
Offer a terse response. -1.97e+12. In the year 2007, what is the difference between the Taxes (in US$) in El Salvador and Taxes (in US$) in Faeroe Islands?
Offer a very short reply. -1.96e+08. In the year 2007, what is the difference between the Taxes (in US$) of El Salvador and Taxes (in US$) of Kosovo?
Provide a succinct answer. 1.10e+09. In the year 2007, what is the difference between the Taxes (in US$) of El Salvador and Taxes (in US$) of Lao PDR?
Offer a very short reply. -2.28e+12. In the year 2007, what is the difference between the Taxes (in US$) of Faeroe Islands and Taxes (in US$) of Kosovo?
Ensure brevity in your answer.  1.29e+09. In the year 2007, what is the difference between the Taxes (in US$) in Faeroe Islands and Taxes (in US$) in Lao PDR?
Provide a short and direct response. -2.28e+12. In the year 2007, what is the difference between the Taxes (in US$) of Kosovo and Taxes (in US$) of Lao PDR?
Your answer should be compact. -2.28e+12. In the year 2008, what is the difference between the Taxes (in US$) of El Salvador and Taxes (in US$) of Faeroe Islands?
Give a very brief answer. -8.70e+06. In the year 2008, what is the difference between the Taxes (in US$) of El Salvador and Taxes (in US$) of Kosovo?
Keep it short and to the point. 1.18e+09. In the year 2008, what is the difference between the Taxes (in US$) of El Salvador and Taxes (in US$) of Lao PDR?
Provide a short and direct response. -2.67e+12. In the year 2008, what is the difference between the Taxes (in US$) of Faeroe Islands and Taxes (in US$) of Kosovo?
Provide a succinct answer. 1.19e+09. In the year 2008, what is the difference between the Taxes (in US$) in Faeroe Islands and Taxes (in US$) in Lao PDR?
Your answer should be very brief. -2.67e+12. In the year 2008, what is the difference between the Taxes (in US$) in Kosovo and Taxes (in US$) in Lao PDR?
Your answer should be compact. -2.68e+12. In the year 2009, what is the difference between the Taxes (in US$) in El Salvador and Taxes (in US$) in Faeroe Islands?
Ensure brevity in your answer.  -6.63e+07. In the year 2009, what is the difference between the Taxes (in US$) of El Salvador and Taxes (in US$) of Kosovo?
Make the answer very short. 9.08e+08. In the year 2009, what is the difference between the Taxes (in US$) of El Salvador and Taxes (in US$) of Lao PDR?
Make the answer very short. -2.79e+12. In the year 2009, what is the difference between the Taxes (in US$) of Faeroe Islands and Taxes (in US$) of Kosovo?
Your answer should be compact. 9.74e+08. In the year 2009, what is the difference between the Taxes (in US$) of Faeroe Islands and Taxes (in US$) of Lao PDR?
Your answer should be very brief. -2.79e+12. In the year 2009, what is the difference between the Taxes (in US$) of Kosovo and Taxes (in US$) of Lao PDR?
Give a very brief answer. -2.79e+12. In the year 2010, what is the difference between the Taxes (in US$) in El Salvador and Taxes (in US$) in Faeroe Islands?
Offer a terse response. 2.12e+07. In the year 2010, what is the difference between the Taxes (in US$) in El Salvador and Taxes (in US$) in Kosovo?
Offer a terse response. 9.72e+08. In the year 2010, what is the difference between the Taxes (in US$) in El Salvador and Taxes (in US$) in Lao PDR?
Give a very brief answer. -3.33e+12. In the year 2010, what is the difference between the Taxes (in US$) in Faeroe Islands and Taxes (in US$) in Kosovo?
Offer a very short reply. 9.51e+08. In the year 2010, what is the difference between the Taxes (in US$) in Faeroe Islands and Taxes (in US$) in Lao PDR?
Ensure brevity in your answer.  -3.33e+12. In the year 2010, what is the difference between the Taxes (in US$) of Kosovo and Taxes (in US$) of Lao PDR?
Provide a short and direct response. -3.33e+12. In the year 2011, what is the difference between the Taxes (in US$) in El Salvador and Taxes (in US$) in Faeroe Islands?
Make the answer very short. 3.03e+08. In the year 2011, what is the difference between the Taxes (in US$) of El Salvador and Taxes (in US$) of Kosovo?
Keep it short and to the point. 1.08e+09. In the year 2011, what is the difference between the Taxes (in US$) of El Salvador and Taxes (in US$) of Lao PDR?
Provide a short and direct response. -3.76e+12. In the year 2011, what is the difference between the Taxes (in US$) of Faeroe Islands and Taxes (in US$) of Kosovo?
Your response must be concise. 7.78e+08. In the year 2011, what is the difference between the Taxes (in US$) in Faeroe Islands and Taxes (in US$) in Lao PDR?
Give a very brief answer. -3.76e+12. In the year 2011, what is the difference between the Taxes (in US$) of Kosovo and Taxes (in US$) of Lao PDR?
Ensure brevity in your answer.  -3.76e+12. In the year 2012, what is the difference between the Taxes (in US$) of El Salvador and Taxes (in US$) of Faeroe Islands?
Provide a succinct answer. 3.25e+08. In the year 2012, what is the difference between the Taxes (in US$) in El Salvador and Taxes (in US$) in Kosovo?
Provide a succinct answer. 1.14e+09. In the year 2012, what is the difference between the Taxes (in US$) in El Salvador and Taxes (in US$) in Lao PDR?
Keep it short and to the point. -4.23e+12. In the year 2012, what is the difference between the Taxes (in US$) of Faeroe Islands and Taxes (in US$) of Kosovo?
Keep it short and to the point. 8.14e+08. In the year 2012, what is the difference between the Taxes (in US$) of Faeroe Islands and Taxes (in US$) of Lao PDR?
Provide a succinct answer. -4.24e+12. In the year 2012, what is the difference between the Taxes (in US$) in Kosovo and Taxes (in US$) in Lao PDR?
Your response must be concise. -4.24e+12. In the year 2013, what is the difference between the Taxes (in US$) of El Salvador and Taxes (in US$) of Faeroe Islands?
Keep it short and to the point. 4.03e+08. In the year 2013, what is the difference between the Taxes (in US$) in El Salvador and Taxes (in US$) in Kosovo?
Your response must be concise. 1.20e+09. In the year 2013, what is the difference between the Taxes (in US$) in El Salvador and Taxes (in US$) in Lao PDR?
Your answer should be very brief. -4.97e+12. In the year 2013, what is the difference between the Taxes (in US$) of Faeroe Islands and Taxes (in US$) of Kosovo?
Make the answer very short. 8.02e+08. In the year 2013, what is the difference between the Taxes (in US$) in Faeroe Islands and Taxes (in US$) in Lao PDR?
Ensure brevity in your answer.  -4.97e+12. In the year 2013, what is the difference between the Taxes (in US$) in Kosovo and Taxes (in US$) in Lao PDR?
Your answer should be very brief. -4.97e+12. What is the ratio of the Taxes (in US$) in El Salvador in 2006 to that in 2007?
Your answer should be very brief. 0.89. What is the ratio of the Taxes (in US$) in Faeroe Islands in 2006 to that in 2007?
Offer a very short reply. 0.89. What is the ratio of the Taxes (in US$) of Kosovo in 2006 to that in 2007?
Ensure brevity in your answer.  0.91. What is the ratio of the Taxes (in US$) in Lao PDR in 2006 to that in 2007?
Ensure brevity in your answer.  0.87. What is the ratio of the Taxes (in US$) of El Salvador in 2006 to that in 2008?
Offer a terse response. 0.84. What is the ratio of the Taxes (in US$) of Faeroe Islands in 2006 to that in 2008?
Make the answer very short. 0.94. What is the ratio of the Taxes (in US$) of Kosovo in 2006 to that in 2008?
Provide a succinct answer. 0.9. What is the ratio of the Taxes (in US$) of Lao PDR in 2006 to that in 2008?
Ensure brevity in your answer.  0.74. What is the ratio of the Taxes (in US$) of El Salvador in 2006 to that in 2009?
Provide a short and direct response. 0.99. What is the ratio of the Taxes (in US$) in Faeroe Islands in 2006 to that in 2009?
Offer a very short reply. 1.06. What is the ratio of the Taxes (in US$) in Kosovo in 2006 to that in 2009?
Provide a short and direct response. 0.87. What is the ratio of the Taxes (in US$) in Lao PDR in 2006 to that in 2009?
Provide a short and direct response. 0.71. What is the ratio of the Taxes (in US$) in El Salvador in 2006 to that in 2010?
Keep it short and to the point. 0.89. What is the ratio of the Taxes (in US$) in Faeroe Islands in 2006 to that in 2010?
Your response must be concise. 1.01. What is the ratio of the Taxes (in US$) in Kosovo in 2006 to that in 2010?
Keep it short and to the point. 0.75. What is the ratio of the Taxes (in US$) in Lao PDR in 2006 to that in 2010?
Offer a very short reply. 0.59. What is the ratio of the Taxes (in US$) in El Salvador in 2006 to that in 2011?
Ensure brevity in your answer.  0.77. What is the ratio of the Taxes (in US$) of Faeroe Islands in 2006 to that in 2011?
Offer a very short reply. 1.02. What is the ratio of the Taxes (in US$) in Kosovo in 2006 to that in 2011?
Ensure brevity in your answer.  0.61. What is the ratio of the Taxes (in US$) in Lao PDR in 2006 to that in 2011?
Your answer should be very brief. 0.52. What is the ratio of the Taxes (in US$) of El Salvador in 2006 to that in 2012?
Make the answer very short. 0.74. What is the ratio of the Taxes (in US$) in Faeroe Islands in 2006 to that in 2012?
Your answer should be compact. 0.99. What is the ratio of the Taxes (in US$) of Kosovo in 2006 to that in 2012?
Provide a succinct answer. 0.6. What is the ratio of the Taxes (in US$) of Lao PDR in 2006 to that in 2012?
Give a very brief answer. 0.47. What is the ratio of the Taxes (in US$) in El Salvador in 2006 to that in 2013?
Your response must be concise. 0.71. What is the ratio of the Taxes (in US$) in Kosovo in 2006 to that in 2013?
Your answer should be compact. 0.6. What is the ratio of the Taxes (in US$) in Lao PDR in 2006 to that in 2013?
Make the answer very short. 0.4. What is the ratio of the Taxes (in US$) of El Salvador in 2007 to that in 2008?
Ensure brevity in your answer.  0.95. What is the ratio of the Taxes (in US$) in Faeroe Islands in 2007 to that in 2008?
Your answer should be very brief. 1.06. What is the ratio of the Taxes (in US$) of Lao PDR in 2007 to that in 2008?
Make the answer very short. 0.85. What is the ratio of the Taxes (in US$) of El Salvador in 2007 to that in 2009?
Provide a short and direct response. 1.11. What is the ratio of the Taxes (in US$) of Faeroe Islands in 2007 to that in 2009?
Make the answer very short. 1.19. What is the ratio of the Taxes (in US$) in Kosovo in 2007 to that in 2009?
Your answer should be compact. 0.96. What is the ratio of the Taxes (in US$) of Lao PDR in 2007 to that in 2009?
Your response must be concise. 0.82. What is the ratio of the Taxes (in US$) in Faeroe Islands in 2007 to that in 2010?
Provide a succinct answer. 1.13. What is the ratio of the Taxes (in US$) in Kosovo in 2007 to that in 2010?
Offer a terse response. 0.82. What is the ratio of the Taxes (in US$) in Lao PDR in 2007 to that in 2010?
Give a very brief answer. 0.68. What is the ratio of the Taxes (in US$) of El Salvador in 2007 to that in 2011?
Offer a terse response. 0.86. What is the ratio of the Taxes (in US$) in Faeroe Islands in 2007 to that in 2011?
Your answer should be compact. 1.14. What is the ratio of the Taxes (in US$) in Kosovo in 2007 to that in 2011?
Make the answer very short. 0.68. What is the ratio of the Taxes (in US$) of Lao PDR in 2007 to that in 2011?
Keep it short and to the point. 0.61. What is the ratio of the Taxes (in US$) of El Salvador in 2007 to that in 2012?
Give a very brief answer. 0.83. What is the ratio of the Taxes (in US$) in Faeroe Islands in 2007 to that in 2012?
Your answer should be very brief. 1.1. What is the ratio of the Taxes (in US$) of Kosovo in 2007 to that in 2012?
Give a very brief answer. 0.66. What is the ratio of the Taxes (in US$) of Lao PDR in 2007 to that in 2012?
Give a very brief answer. 0.54. What is the ratio of the Taxes (in US$) in El Salvador in 2007 to that in 2013?
Give a very brief answer. 0.8. What is the ratio of the Taxes (in US$) in Faeroe Islands in 2007 to that in 2013?
Provide a succinct answer. 1.11. What is the ratio of the Taxes (in US$) in Kosovo in 2007 to that in 2013?
Make the answer very short. 0.66. What is the ratio of the Taxes (in US$) in Lao PDR in 2007 to that in 2013?
Offer a very short reply. 0.46. What is the ratio of the Taxes (in US$) in El Salvador in 2008 to that in 2009?
Provide a short and direct response. 1.17. What is the ratio of the Taxes (in US$) in Faeroe Islands in 2008 to that in 2009?
Provide a succinct answer. 1.12. What is the ratio of the Taxes (in US$) of Kosovo in 2008 to that in 2009?
Offer a very short reply. 0.97. What is the ratio of the Taxes (in US$) in Lao PDR in 2008 to that in 2009?
Your answer should be compact. 0.96. What is the ratio of the Taxes (in US$) of El Salvador in 2008 to that in 2010?
Offer a very short reply. 1.05. What is the ratio of the Taxes (in US$) of Faeroe Islands in 2008 to that in 2010?
Give a very brief answer. 1.07. What is the ratio of the Taxes (in US$) of Kosovo in 2008 to that in 2010?
Keep it short and to the point. 0.83. What is the ratio of the Taxes (in US$) in Lao PDR in 2008 to that in 2010?
Offer a terse response. 0.8. What is the ratio of the Taxes (in US$) of El Salvador in 2008 to that in 2011?
Ensure brevity in your answer.  0.91. What is the ratio of the Taxes (in US$) in Faeroe Islands in 2008 to that in 2011?
Offer a very short reply. 1.08. What is the ratio of the Taxes (in US$) of Kosovo in 2008 to that in 2011?
Offer a very short reply. 0.68. What is the ratio of the Taxes (in US$) of Lao PDR in 2008 to that in 2011?
Ensure brevity in your answer.  0.71. What is the ratio of the Taxes (in US$) in El Salvador in 2008 to that in 2012?
Your response must be concise. 0.87. What is the ratio of the Taxes (in US$) in Faeroe Islands in 2008 to that in 2012?
Your answer should be very brief. 1.05. What is the ratio of the Taxes (in US$) of Kosovo in 2008 to that in 2012?
Your response must be concise. 0.66. What is the ratio of the Taxes (in US$) in Lao PDR in 2008 to that in 2012?
Your answer should be compact. 0.63. What is the ratio of the Taxes (in US$) of El Salvador in 2008 to that in 2013?
Your answer should be compact. 0.85. What is the ratio of the Taxes (in US$) in Faeroe Islands in 2008 to that in 2013?
Give a very brief answer. 1.05. What is the ratio of the Taxes (in US$) of Kosovo in 2008 to that in 2013?
Provide a short and direct response. 0.66. What is the ratio of the Taxes (in US$) of Lao PDR in 2008 to that in 2013?
Your response must be concise. 0.54. What is the ratio of the Taxes (in US$) of El Salvador in 2009 to that in 2010?
Your answer should be very brief. 0.9. What is the ratio of the Taxes (in US$) of Faeroe Islands in 2009 to that in 2010?
Make the answer very short. 0.95. What is the ratio of the Taxes (in US$) of Kosovo in 2009 to that in 2010?
Give a very brief answer. 0.85. What is the ratio of the Taxes (in US$) in Lao PDR in 2009 to that in 2010?
Your answer should be compact. 0.84. What is the ratio of the Taxes (in US$) in El Salvador in 2009 to that in 2011?
Your response must be concise. 0.78. What is the ratio of the Taxes (in US$) in Faeroe Islands in 2009 to that in 2011?
Your answer should be very brief. 0.96. What is the ratio of the Taxes (in US$) in Kosovo in 2009 to that in 2011?
Your answer should be very brief. 0.7. What is the ratio of the Taxes (in US$) of Lao PDR in 2009 to that in 2011?
Ensure brevity in your answer.  0.74. What is the ratio of the Taxes (in US$) of El Salvador in 2009 to that in 2012?
Ensure brevity in your answer.  0.75. What is the ratio of the Taxes (in US$) in Faeroe Islands in 2009 to that in 2012?
Provide a succinct answer. 0.93. What is the ratio of the Taxes (in US$) of Kosovo in 2009 to that in 2012?
Provide a short and direct response. 0.68. What is the ratio of the Taxes (in US$) in Lao PDR in 2009 to that in 2012?
Offer a terse response. 0.66. What is the ratio of the Taxes (in US$) of El Salvador in 2009 to that in 2013?
Give a very brief answer. 0.72. What is the ratio of the Taxes (in US$) of Faeroe Islands in 2009 to that in 2013?
Keep it short and to the point. 0.94. What is the ratio of the Taxes (in US$) of Kosovo in 2009 to that in 2013?
Give a very brief answer. 0.69. What is the ratio of the Taxes (in US$) of Lao PDR in 2009 to that in 2013?
Provide a succinct answer. 0.56. What is the ratio of the Taxes (in US$) of El Salvador in 2010 to that in 2011?
Give a very brief answer. 0.86. What is the ratio of the Taxes (in US$) in Faeroe Islands in 2010 to that in 2011?
Keep it short and to the point. 1.01. What is the ratio of the Taxes (in US$) of Kosovo in 2010 to that in 2011?
Your answer should be compact. 0.82. What is the ratio of the Taxes (in US$) in Lao PDR in 2010 to that in 2011?
Offer a very short reply. 0.89. What is the ratio of the Taxes (in US$) of El Salvador in 2010 to that in 2012?
Provide a succinct answer. 0.83. What is the ratio of the Taxes (in US$) of Faeroe Islands in 2010 to that in 2012?
Your response must be concise. 0.98. What is the ratio of the Taxes (in US$) of Kosovo in 2010 to that in 2012?
Give a very brief answer. 0.8. What is the ratio of the Taxes (in US$) in Lao PDR in 2010 to that in 2012?
Your answer should be compact. 0.79. What is the ratio of the Taxes (in US$) of El Salvador in 2010 to that in 2013?
Make the answer very short. 0.81. What is the ratio of the Taxes (in US$) of Faeroe Islands in 2010 to that in 2013?
Ensure brevity in your answer.  0.98. What is the ratio of the Taxes (in US$) in Kosovo in 2010 to that in 2013?
Your answer should be very brief. 0.8. What is the ratio of the Taxes (in US$) in Lao PDR in 2010 to that in 2013?
Provide a short and direct response. 0.67. What is the ratio of the Taxes (in US$) of El Salvador in 2011 to that in 2012?
Offer a very short reply. 0.96. What is the ratio of the Taxes (in US$) of Faeroe Islands in 2011 to that in 2012?
Make the answer very short. 0.97. What is the ratio of the Taxes (in US$) of Kosovo in 2011 to that in 2012?
Make the answer very short. 0.98. What is the ratio of the Taxes (in US$) in Lao PDR in 2011 to that in 2012?
Offer a terse response. 0.89. What is the ratio of the Taxes (in US$) in El Salvador in 2011 to that in 2013?
Your answer should be compact. 0.93. What is the ratio of the Taxes (in US$) of Faeroe Islands in 2011 to that in 2013?
Provide a short and direct response. 0.97. What is the ratio of the Taxes (in US$) of Kosovo in 2011 to that in 2013?
Make the answer very short. 0.98. What is the ratio of the Taxes (in US$) in Lao PDR in 2011 to that in 2013?
Keep it short and to the point. 0.76. What is the ratio of the Taxes (in US$) in El Salvador in 2012 to that in 2013?
Your answer should be compact. 0.97. What is the ratio of the Taxes (in US$) of Faeroe Islands in 2012 to that in 2013?
Your answer should be compact. 1.01. What is the ratio of the Taxes (in US$) of Lao PDR in 2012 to that in 2013?
Keep it short and to the point. 0.85. What is the difference between the highest and the second highest Taxes (in US$) of El Salvador?
Your response must be concise. 6.53e+07. What is the difference between the highest and the second highest Taxes (in US$) of Faeroe Islands?
Your answer should be compact. 9.90e+07. What is the difference between the highest and the second highest Taxes (in US$) in Kosovo?
Ensure brevity in your answer.  7.00e+05. What is the difference between the highest and the second highest Taxes (in US$) of Lao PDR?
Provide a short and direct response. 7.37e+11. What is the difference between the highest and the lowest Taxes (in US$) in El Salvador?
Your answer should be compact. 5.97e+08. What is the difference between the highest and the lowest Taxes (in US$) in Faeroe Islands?
Your response must be concise. 2.97e+08. What is the difference between the highest and the lowest Taxes (in US$) of Kosovo?
Give a very brief answer. 3.58e+08. What is the difference between the highest and the lowest Taxes (in US$) of Lao PDR?
Your answer should be compact. 3.00e+12. 